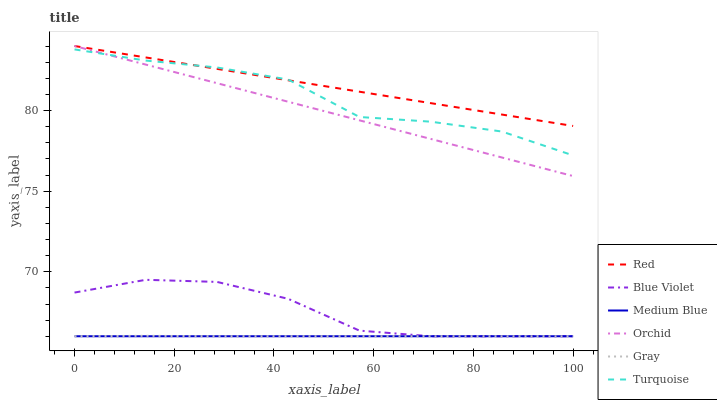Does Medium Blue have the minimum area under the curve?
Answer yes or no. Yes. Does Red have the maximum area under the curve?
Answer yes or no. Yes. Does Turquoise have the minimum area under the curve?
Answer yes or no. No. Does Turquoise have the maximum area under the curve?
Answer yes or no. No. Is Medium Blue the smoothest?
Answer yes or no. Yes. Is Turquoise the roughest?
Answer yes or no. Yes. Is Turquoise the smoothest?
Answer yes or no. No. Is Medium Blue the roughest?
Answer yes or no. No. Does Gray have the lowest value?
Answer yes or no. Yes. Does Turquoise have the lowest value?
Answer yes or no. No. Does Orchid have the highest value?
Answer yes or no. Yes. Does Turquoise have the highest value?
Answer yes or no. No. Is Gray less than Red?
Answer yes or no. Yes. Is Turquoise greater than Gray?
Answer yes or no. Yes. Does Orchid intersect Red?
Answer yes or no. Yes. Is Orchid less than Red?
Answer yes or no. No. Is Orchid greater than Red?
Answer yes or no. No. Does Gray intersect Red?
Answer yes or no. No. 